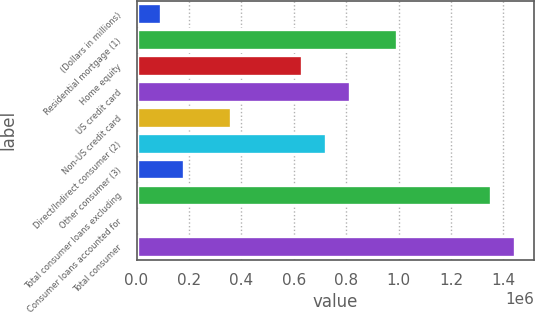<chart> <loc_0><loc_0><loc_500><loc_500><bar_chart><fcel>(Dollars in millions)<fcel>Residential mortgage (1)<fcel>Home equity<fcel>US credit card<fcel>Non-US credit card<fcel>Direct/Indirect consumer (2)<fcel>Other consumer (3)<fcel>Total consumer loans excluding<fcel>Consumer loans accounted for<fcel>Total consumer<nl><fcel>91984<fcel>993114<fcel>632662<fcel>812888<fcel>362323<fcel>722775<fcel>182097<fcel>1.35357e+06<fcel>1871<fcel>1.44368e+06<nl></chart> 